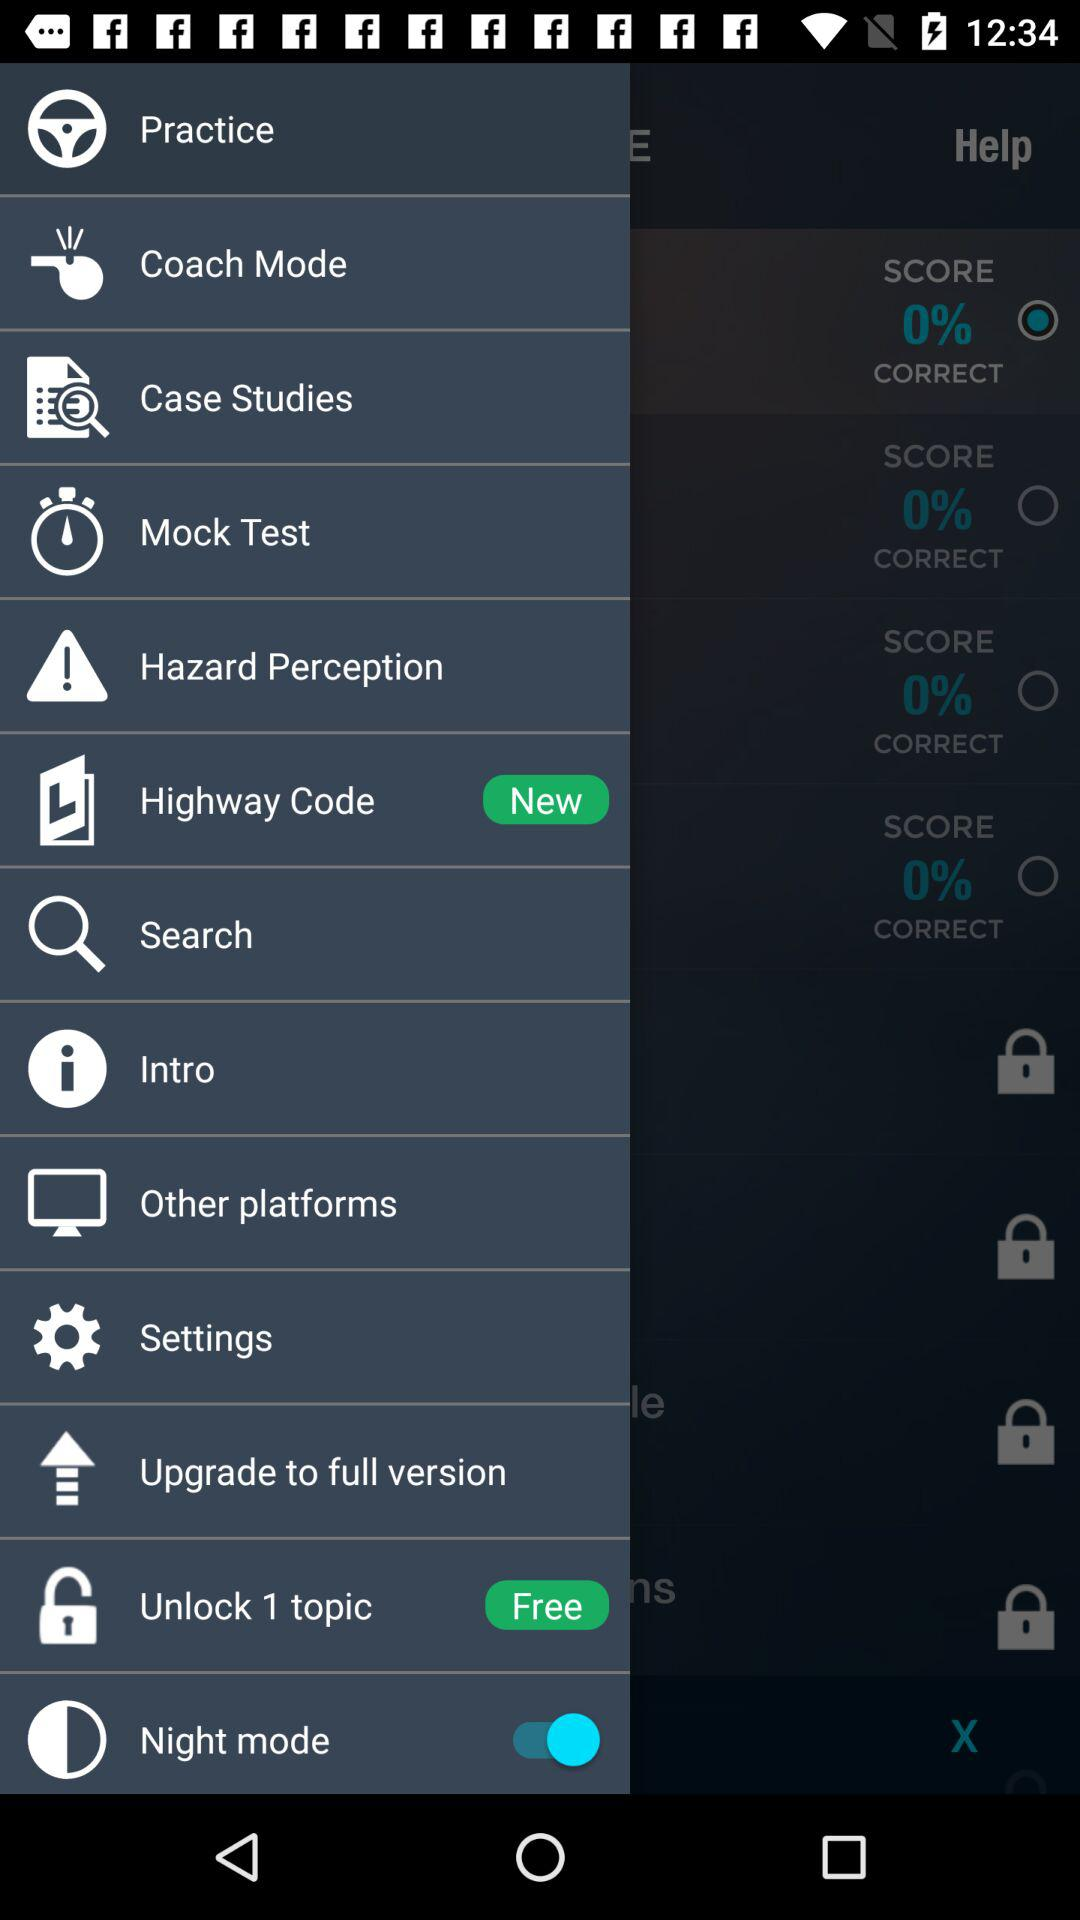What is the status of the "Night mode"? The status of the "Night mode" is "on". 